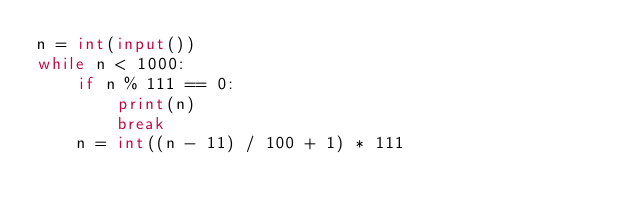Convert code to text. <code><loc_0><loc_0><loc_500><loc_500><_Python_>n = int(input())
while n < 1000:
    if n % 111 == 0:
        print(n)
        break
    n = int((n - 11) / 100 + 1) * 111
</code> 